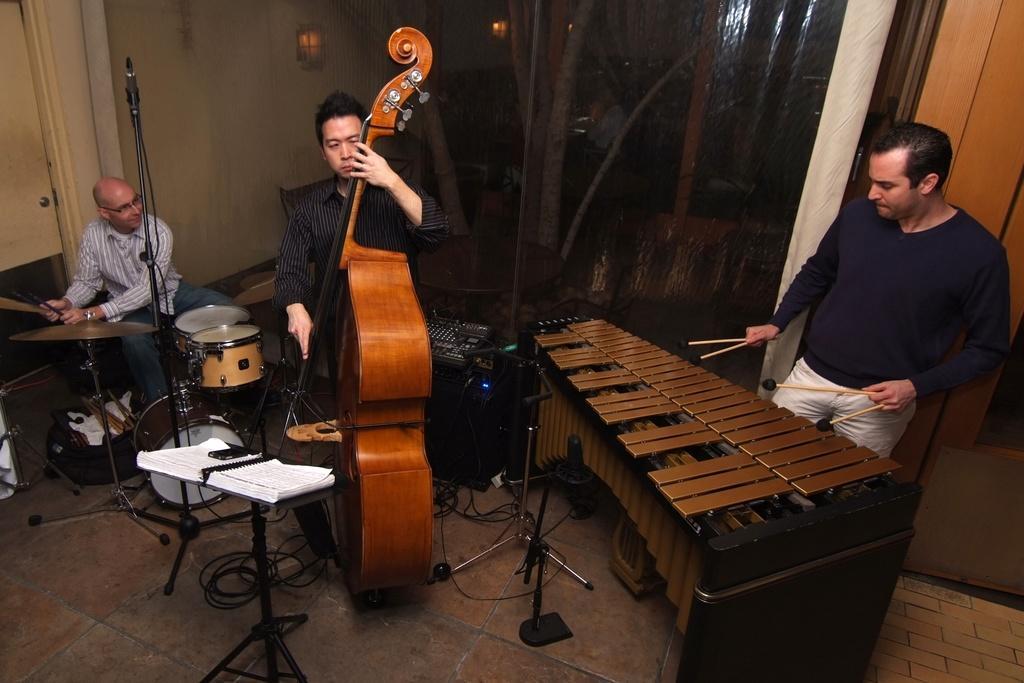Could you give a brief overview of what you see in this image? There are three people in the image. The person at a right side is standing and playing a musical instrument. The person in the middle is standing and playing cello instrument. The person at the left is sitting and playing drums. this is a book holder with a stand. At background I can see a lamp attached to the wall. 